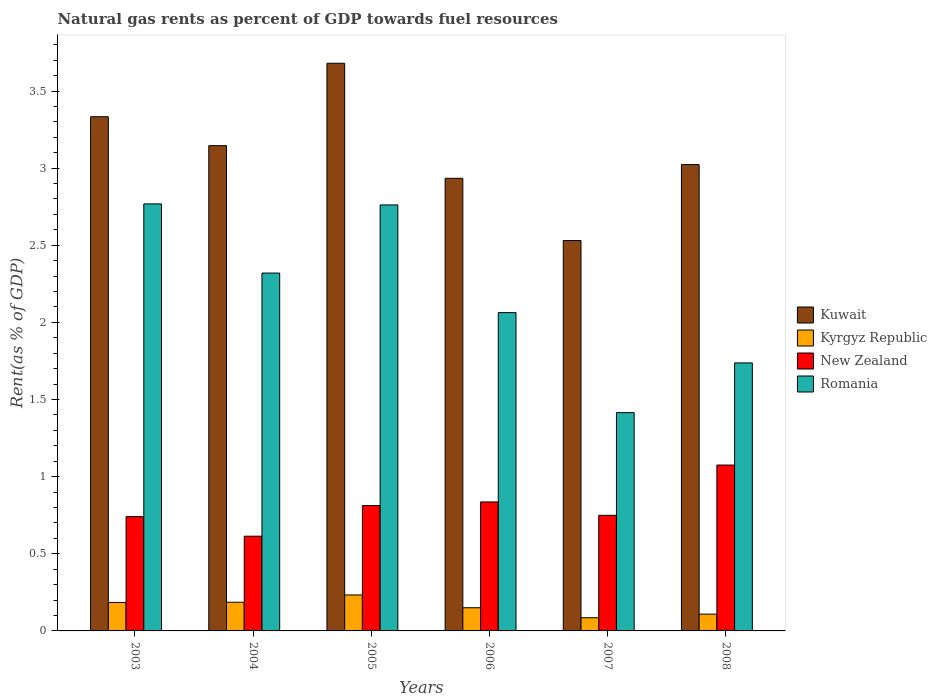How many groups of bars are there?
Give a very brief answer. 6. What is the label of the 6th group of bars from the left?
Your response must be concise. 2008. What is the matural gas rent in New Zealand in 2005?
Give a very brief answer. 0.81. Across all years, what is the maximum matural gas rent in Romania?
Keep it short and to the point. 2.77. Across all years, what is the minimum matural gas rent in Romania?
Offer a very short reply. 1.42. In which year was the matural gas rent in New Zealand maximum?
Offer a terse response. 2008. What is the total matural gas rent in Romania in the graph?
Your response must be concise. 13.07. What is the difference between the matural gas rent in Romania in 2004 and that in 2007?
Ensure brevity in your answer.  0.9. What is the difference between the matural gas rent in Romania in 2008 and the matural gas rent in New Zealand in 2005?
Provide a succinct answer. 0.92. What is the average matural gas rent in New Zealand per year?
Your answer should be compact. 0.8. In the year 2007, what is the difference between the matural gas rent in Romania and matural gas rent in Kyrgyz Republic?
Ensure brevity in your answer.  1.33. What is the ratio of the matural gas rent in New Zealand in 2005 to that in 2006?
Give a very brief answer. 0.97. Is the matural gas rent in Kyrgyz Republic in 2004 less than that in 2006?
Offer a terse response. No. Is the difference between the matural gas rent in Romania in 2004 and 2008 greater than the difference between the matural gas rent in Kyrgyz Republic in 2004 and 2008?
Keep it short and to the point. Yes. What is the difference between the highest and the second highest matural gas rent in Kuwait?
Provide a succinct answer. 0.35. What is the difference between the highest and the lowest matural gas rent in Kyrgyz Republic?
Your answer should be very brief. 0.15. What does the 2nd bar from the left in 2004 represents?
Keep it short and to the point. Kyrgyz Republic. What does the 4th bar from the right in 2007 represents?
Provide a short and direct response. Kuwait. Is it the case that in every year, the sum of the matural gas rent in Kuwait and matural gas rent in Romania is greater than the matural gas rent in New Zealand?
Ensure brevity in your answer.  Yes. How many bars are there?
Provide a succinct answer. 24. Are the values on the major ticks of Y-axis written in scientific E-notation?
Provide a succinct answer. No. Does the graph contain any zero values?
Offer a very short reply. No. How many legend labels are there?
Keep it short and to the point. 4. What is the title of the graph?
Keep it short and to the point. Natural gas rents as percent of GDP towards fuel resources. Does "Sao Tome and Principe" appear as one of the legend labels in the graph?
Offer a very short reply. No. What is the label or title of the Y-axis?
Provide a succinct answer. Rent(as % of GDP). What is the Rent(as % of GDP) of Kuwait in 2003?
Make the answer very short. 3.33. What is the Rent(as % of GDP) of Kyrgyz Republic in 2003?
Your answer should be very brief. 0.18. What is the Rent(as % of GDP) in New Zealand in 2003?
Your answer should be very brief. 0.74. What is the Rent(as % of GDP) of Romania in 2003?
Give a very brief answer. 2.77. What is the Rent(as % of GDP) in Kuwait in 2004?
Your answer should be compact. 3.15. What is the Rent(as % of GDP) of Kyrgyz Republic in 2004?
Ensure brevity in your answer.  0.19. What is the Rent(as % of GDP) in New Zealand in 2004?
Make the answer very short. 0.61. What is the Rent(as % of GDP) of Romania in 2004?
Give a very brief answer. 2.32. What is the Rent(as % of GDP) in Kuwait in 2005?
Ensure brevity in your answer.  3.68. What is the Rent(as % of GDP) in Kyrgyz Republic in 2005?
Make the answer very short. 0.23. What is the Rent(as % of GDP) in New Zealand in 2005?
Provide a succinct answer. 0.81. What is the Rent(as % of GDP) of Romania in 2005?
Offer a very short reply. 2.76. What is the Rent(as % of GDP) of Kuwait in 2006?
Your answer should be compact. 2.93. What is the Rent(as % of GDP) in Kyrgyz Republic in 2006?
Offer a very short reply. 0.15. What is the Rent(as % of GDP) of New Zealand in 2006?
Give a very brief answer. 0.84. What is the Rent(as % of GDP) of Romania in 2006?
Provide a short and direct response. 2.06. What is the Rent(as % of GDP) in Kuwait in 2007?
Give a very brief answer. 2.53. What is the Rent(as % of GDP) of Kyrgyz Republic in 2007?
Offer a terse response. 0.09. What is the Rent(as % of GDP) of New Zealand in 2007?
Make the answer very short. 0.75. What is the Rent(as % of GDP) of Romania in 2007?
Your answer should be very brief. 1.42. What is the Rent(as % of GDP) in Kuwait in 2008?
Provide a succinct answer. 3.02. What is the Rent(as % of GDP) in Kyrgyz Republic in 2008?
Your answer should be very brief. 0.11. What is the Rent(as % of GDP) in New Zealand in 2008?
Your answer should be compact. 1.08. What is the Rent(as % of GDP) in Romania in 2008?
Ensure brevity in your answer.  1.74. Across all years, what is the maximum Rent(as % of GDP) in Kuwait?
Your response must be concise. 3.68. Across all years, what is the maximum Rent(as % of GDP) in Kyrgyz Republic?
Keep it short and to the point. 0.23. Across all years, what is the maximum Rent(as % of GDP) of New Zealand?
Offer a very short reply. 1.08. Across all years, what is the maximum Rent(as % of GDP) of Romania?
Keep it short and to the point. 2.77. Across all years, what is the minimum Rent(as % of GDP) of Kuwait?
Provide a succinct answer. 2.53. Across all years, what is the minimum Rent(as % of GDP) of Kyrgyz Republic?
Your response must be concise. 0.09. Across all years, what is the minimum Rent(as % of GDP) of New Zealand?
Offer a terse response. 0.61. Across all years, what is the minimum Rent(as % of GDP) in Romania?
Your answer should be very brief. 1.42. What is the total Rent(as % of GDP) of Kuwait in the graph?
Provide a short and direct response. 18.65. What is the total Rent(as % of GDP) in Kyrgyz Republic in the graph?
Offer a terse response. 0.95. What is the total Rent(as % of GDP) in New Zealand in the graph?
Provide a short and direct response. 4.83. What is the total Rent(as % of GDP) in Romania in the graph?
Offer a very short reply. 13.07. What is the difference between the Rent(as % of GDP) in Kuwait in 2003 and that in 2004?
Your response must be concise. 0.19. What is the difference between the Rent(as % of GDP) of Kyrgyz Republic in 2003 and that in 2004?
Provide a short and direct response. -0. What is the difference between the Rent(as % of GDP) of New Zealand in 2003 and that in 2004?
Make the answer very short. 0.13. What is the difference between the Rent(as % of GDP) of Romania in 2003 and that in 2004?
Ensure brevity in your answer.  0.45. What is the difference between the Rent(as % of GDP) of Kuwait in 2003 and that in 2005?
Make the answer very short. -0.35. What is the difference between the Rent(as % of GDP) in Kyrgyz Republic in 2003 and that in 2005?
Your response must be concise. -0.05. What is the difference between the Rent(as % of GDP) of New Zealand in 2003 and that in 2005?
Keep it short and to the point. -0.07. What is the difference between the Rent(as % of GDP) of Romania in 2003 and that in 2005?
Your answer should be compact. 0.01. What is the difference between the Rent(as % of GDP) of Kuwait in 2003 and that in 2006?
Your answer should be compact. 0.4. What is the difference between the Rent(as % of GDP) in Kyrgyz Republic in 2003 and that in 2006?
Give a very brief answer. 0.03. What is the difference between the Rent(as % of GDP) in New Zealand in 2003 and that in 2006?
Your answer should be compact. -0.1. What is the difference between the Rent(as % of GDP) of Romania in 2003 and that in 2006?
Provide a short and direct response. 0.7. What is the difference between the Rent(as % of GDP) in Kuwait in 2003 and that in 2007?
Provide a succinct answer. 0.8. What is the difference between the Rent(as % of GDP) of Kyrgyz Republic in 2003 and that in 2007?
Make the answer very short. 0.1. What is the difference between the Rent(as % of GDP) of New Zealand in 2003 and that in 2007?
Provide a short and direct response. -0.01. What is the difference between the Rent(as % of GDP) in Romania in 2003 and that in 2007?
Keep it short and to the point. 1.35. What is the difference between the Rent(as % of GDP) of Kuwait in 2003 and that in 2008?
Offer a terse response. 0.31. What is the difference between the Rent(as % of GDP) of Kyrgyz Republic in 2003 and that in 2008?
Your answer should be very brief. 0.08. What is the difference between the Rent(as % of GDP) in New Zealand in 2003 and that in 2008?
Give a very brief answer. -0.33. What is the difference between the Rent(as % of GDP) in Romania in 2003 and that in 2008?
Offer a very short reply. 1.03. What is the difference between the Rent(as % of GDP) in Kuwait in 2004 and that in 2005?
Your response must be concise. -0.53. What is the difference between the Rent(as % of GDP) in Kyrgyz Republic in 2004 and that in 2005?
Your response must be concise. -0.05. What is the difference between the Rent(as % of GDP) of New Zealand in 2004 and that in 2005?
Your response must be concise. -0.2. What is the difference between the Rent(as % of GDP) in Romania in 2004 and that in 2005?
Offer a terse response. -0.44. What is the difference between the Rent(as % of GDP) in Kuwait in 2004 and that in 2006?
Offer a very short reply. 0.21. What is the difference between the Rent(as % of GDP) of Kyrgyz Republic in 2004 and that in 2006?
Offer a terse response. 0.04. What is the difference between the Rent(as % of GDP) in New Zealand in 2004 and that in 2006?
Ensure brevity in your answer.  -0.22. What is the difference between the Rent(as % of GDP) of Romania in 2004 and that in 2006?
Give a very brief answer. 0.26. What is the difference between the Rent(as % of GDP) in Kuwait in 2004 and that in 2007?
Offer a terse response. 0.61. What is the difference between the Rent(as % of GDP) in Kyrgyz Republic in 2004 and that in 2007?
Your answer should be compact. 0.1. What is the difference between the Rent(as % of GDP) in New Zealand in 2004 and that in 2007?
Provide a succinct answer. -0.14. What is the difference between the Rent(as % of GDP) in Romania in 2004 and that in 2007?
Provide a succinct answer. 0.9. What is the difference between the Rent(as % of GDP) of Kuwait in 2004 and that in 2008?
Offer a terse response. 0.12. What is the difference between the Rent(as % of GDP) of Kyrgyz Republic in 2004 and that in 2008?
Your answer should be very brief. 0.08. What is the difference between the Rent(as % of GDP) in New Zealand in 2004 and that in 2008?
Your answer should be compact. -0.46. What is the difference between the Rent(as % of GDP) in Romania in 2004 and that in 2008?
Your answer should be very brief. 0.58. What is the difference between the Rent(as % of GDP) in Kuwait in 2005 and that in 2006?
Offer a terse response. 0.75. What is the difference between the Rent(as % of GDP) in Kyrgyz Republic in 2005 and that in 2006?
Ensure brevity in your answer.  0.08. What is the difference between the Rent(as % of GDP) of New Zealand in 2005 and that in 2006?
Keep it short and to the point. -0.02. What is the difference between the Rent(as % of GDP) in Romania in 2005 and that in 2006?
Your answer should be compact. 0.7. What is the difference between the Rent(as % of GDP) in Kuwait in 2005 and that in 2007?
Your answer should be very brief. 1.15. What is the difference between the Rent(as % of GDP) in Kyrgyz Republic in 2005 and that in 2007?
Offer a terse response. 0.15. What is the difference between the Rent(as % of GDP) of New Zealand in 2005 and that in 2007?
Ensure brevity in your answer.  0.06. What is the difference between the Rent(as % of GDP) in Romania in 2005 and that in 2007?
Offer a very short reply. 1.35. What is the difference between the Rent(as % of GDP) of Kuwait in 2005 and that in 2008?
Offer a very short reply. 0.66. What is the difference between the Rent(as % of GDP) of Kyrgyz Republic in 2005 and that in 2008?
Keep it short and to the point. 0.12. What is the difference between the Rent(as % of GDP) of New Zealand in 2005 and that in 2008?
Offer a terse response. -0.26. What is the difference between the Rent(as % of GDP) of Romania in 2005 and that in 2008?
Your answer should be compact. 1.02. What is the difference between the Rent(as % of GDP) of Kuwait in 2006 and that in 2007?
Ensure brevity in your answer.  0.4. What is the difference between the Rent(as % of GDP) in Kyrgyz Republic in 2006 and that in 2007?
Your answer should be very brief. 0.06. What is the difference between the Rent(as % of GDP) in New Zealand in 2006 and that in 2007?
Give a very brief answer. 0.09. What is the difference between the Rent(as % of GDP) in Romania in 2006 and that in 2007?
Your answer should be compact. 0.65. What is the difference between the Rent(as % of GDP) in Kuwait in 2006 and that in 2008?
Give a very brief answer. -0.09. What is the difference between the Rent(as % of GDP) of Kyrgyz Republic in 2006 and that in 2008?
Offer a very short reply. 0.04. What is the difference between the Rent(as % of GDP) of New Zealand in 2006 and that in 2008?
Give a very brief answer. -0.24. What is the difference between the Rent(as % of GDP) of Romania in 2006 and that in 2008?
Your answer should be compact. 0.33. What is the difference between the Rent(as % of GDP) of Kuwait in 2007 and that in 2008?
Your answer should be compact. -0.49. What is the difference between the Rent(as % of GDP) of Kyrgyz Republic in 2007 and that in 2008?
Offer a very short reply. -0.02. What is the difference between the Rent(as % of GDP) in New Zealand in 2007 and that in 2008?
Your response must be concise. -0.33. What is the difference between the Rent(as % of GDP) of Romania in 2007 and that in 2008?
Your response must be concise. -0.32. What is the difference between the Rent(as % of GDP) in Kuwait in 2003 and the Rent(as % of GDP) in Kyrgyz Republic in 2004?
Offer a terse response. 3.15. What is the difference between the Rent(as % of GDP) of Kuwait in 2003 and the Rent(as % of GDP) of New Zealand in 2004?
Your answer should be very brief. 2.72. What is the difference between the Rent(as % of GDP) in Kuwait in 2003 and the Rent(as % of GDP) in Romania in 2004?
Ensure brevity in your answer.  1.01. What is the difference between the Rent(as % of GDP) of Kyrgyz Republic in 2003 and the Rent(as % of GDP) of New Zealand in 2004?
Ensure brevity in your answer.  -0.43. What is the difference between the Rent(as % of GDP) in Kyrgyz Republic in 2003 and the Rent(as % of GDP) in Romania in 2004?
Offer a very short reply. -2.14. What is the difference between the Rent(as % of GDP) in New Zealand in 2003 and the Rent(as % of GDP) in Romania in 2004?
Your answer should be compact. -1.58. What is the difference between the Rent(as % of GDP) in Kuwait in 2003 and the Rent(as % of GDP) in Kyrgyz Republic in 2005?
Your response must be concise. 3.1. What is the difference between the Rent(as % of GDP) in Kuwait in 2003 and the Rent(as % of GDP) in New Zealand in 2005?
Provide a succinct answer. 2.52. What is the difference between the Rent(as % of GDP) in Kuwait in 2003 and the Rent(as % of GDP) in Romania in 2005?
Give a very brief answer. 0.57. What is the difference between the Rent(as % of GDP) in Kyrgyz Republic in 2003 and the Rent(as % of GDP) in New Zealand in 2005?
Ensure brevity in your answer.  -0.63. What is the difference between the Rent(as % of GDP) in Kyrgyz Republic in 2003 and the Rent(as % of GDP) in Romania in 2005?
Ensure brevity in your answer.  -2.58. What is the difference between the Rent(as % of GDP) of New Zealand in 2003 and the Rent(as % of GDP) of Romania in 2005?
Your answer should be compact. -2.02. What is the difference between the Rent(as % of GDP) in Kuwait in 2003 and the Rent(as % of GDP) in Kyrgyz Republic in 2006?
Give a very brief answer. 3.18. What is the difference between the Rent(as % of GDP) in Kuwait in 2003 and the Rent(as % of GDP) in New Zealand in 2006?
Offer a terse response. 2.5. What is the difference between the Rent(as % of GDP) of Kuwait in 2003 and the Rent(as % of GDP) of Romania in 2006?
Give a very brief answer. 1.27. What is the difference between the Rent(as % of GDP) in Kyrgyz Republic in 2003 and the Rent(as % of GDP) in New Zealand in 2006?
Provide a short and direct response. -0.65. What is the difference between the Rent(as % of GDP) of Kyrgyz Republic in 2003 and the Rent(as % of GDP) of Romania in 2006?
Your response must be concise. -1.88. What is the difference between the Rent(as % of GDP) in New Zealand in 2003 and the Rent(as % of GDP) in Romania in 2006?
Offer a very short reply. -1.32. What is the difference between the Rent(as % of GDP) of Kuwait in 2003 and the Rent(as % of GDP) of Kyrgyz Republic in 2007?
Provide a succinct answer. 3.25. What is the difference between the Rent(as % of GDP) of Kuwait in 2003 and the Rent(as % of GDP) of New Zealand in 2007?
Keep it short and to the point. 2.58. What is the difference between the Rent(as % of GDP) of Kuwait in 2003 and the Rent(as % of GDP) of Romania in 2007?
Your answer should be very brief. 1.92. What is the difference between the Rent(as % of GDP) of Kyrgyz Republic in 2003 and the Rent(as % of GDP) of New Zealand in 2007?
Keep it short and to the point. -0.56. What is the difference between the Rent(as % of GDP) of Kyrgyz Republic in 2003 and the Rent(as % of GDP) of Romania in 2007?
Make the answer very short. -1.23. What is the difference between the Rent(as % of GDP) of New Zealand in 2003 and the Rent(as % of GDP) of Romania in 2007?
Make the answer very short. -0.67. What is the difference between the Rent(as % of GDP) in Kuwait in 2003 and the Rent(as % of GDP) in Kyrgyz Republic in 2008?
Your response must be concise. 3.22. What is the difference between the Rent(as % of GDP) in Kuwait in 2003 and the Rent(as % of GDP) in New Zealand in 2008?
Provide a succinct answer. 2.26. What is the difference between the Rent(as % of GDP) in Kuwait in 2003 and the Rent(as % of GDP) in Romania in 2008?
Provide a succinct answer. 1.6. What is the difference between the Rent(as % of GDP) of Kyrgyz Republic in 2003 and the Rent(as % of GDP) of New Zealand in 2008?
Provide a short and direct response. -0.89. What is the difference between the Rent(as % of GDP) in Kyrgyz Republic in 2003 and the Rent(as % of GDP) in Romania in 2008?
Offer a terse response. -1.55. What is the difference between the Rent(as % of GDP) of New Zealand in 2003 and the Rent(as % of GDP) of Romania in 2008?
Your response must be concise. -1. What is the difference between the Rent(as % of GDP) of Kuwait in 2004 and the Rent(as % of GDP) of Kyrgyz Republic in 2005?
Keep it short and to the point. 2.91. What is the difference between the Rent(as % of GDP) of Kuwait in 2004 and the Rent(as % of GDP) of New Zealand in 2005?
Offer a terse response. 2.33. What is the difference between the Rent(as % of GDP) in Kuwait in 2004 and the Rent(as % of GDP) in Romania in 2005?
Your answer should be very brief. 0.38. What is the difference between the Rent(as % of GDP) in Kyrgyz Republic in 2004 and the Rent(as % of GDP) in New Zealand in 2005?
Offer a terse response. -0.63. What is the difference between the Rent(as % of GDP) of Kyrgyz Republic in 2004 and the Rent(as % of GDP) of Romania in 2005?
Your response must be concise. -2.58. What is the difference between the Rent(as % of GDP) of New Zealand in 2004 and the Rent(as % of GDP) of Romania in 2005?
Keep it short and to the point. -2.15. What is the difference between the Rent(as % of GDP) in Kuwait in 2004 and the Rent(as % of GDP) in Kyrgyz Republic in 2006?
Make the answer very short. 3. What is the difference between the Rent(as % of GDP) in Kuwait in 2004 and the Rent(as % of GDP) in New Zealand in 2006?
Your answer should be very brief. 2.31. What is the difference between the Rent(as % of GDP) in Kuwait in 2004 and the Rent(as % of GDP) in Romania in 2006?
Your answer should be compact. 1.08. What is the difference between the Rent(as % of GDP) in Kyrgyz Republic in 2004 and the Rent(as % of GDP) in New Zealand in 2006?
Ensure brevity in your answer.  -0.65. What is the difference between the Rent(as % of GDP) of Kyrgyz Republic in 2004 and the Rent(as % of GDP) of Romania in 2006?
Keep it short and to the point. -1.88. What is the difference between the Rent(as % of GDP) of New Zealand in 2004 and the Rent(as % of GDP) of Romania in 2006?
Offer a terse response. -1.45. What is the difference between the Rent(as % of GDP) in Kuwait in 2004 and the Rent(as % of GDP) in Kyrgyz Republic in 2007?
Your response must be concise. 3.06. What is the difference between the Rent(as % of GDP) of Kuwait in 2004 and the Rent(as % of GDP) of New Zealand in 2007?
Offer a terse response. 2.4. What is the difference between the Rent(as % of GDP) in Kuwait in 2004 and the Rent(as % of GDP) in Romania in 2007?
Make the answer very short. 1.73. What is the difference between the Rent(as % of GDP) of Kyrgyz Republic in 2004 and the Rent(as % of GDP) of New Zealand in 2007?
Ensure brevity in your answer.  -0.56. What is the difference between the Rent(as % of GDP) in Kyrgyz Republic in 2004 and the Rent(as % of GDP) in Romania in 2007?
Your answer should be very brief. -1.23. What is the difference between the Rent(as % of GDP) of New Zealand in 2004 and the Rent(as % of GDP) of Romania in 2007?
Give a very brief answer. -0.8. What is the difference between the Rent(as % of GDP) of Kuwait in 2004 and the Rent(as % of GDP) of Kyrgyz Republic in 2008?
Offer a very short reply. 3.04. What is the difference between the Rent(as % of GDP) of Kuwait in 2004 and the Rent(as % of GDP) of New Zealand in 2008?
Offer a very short reply. 2.07. What is the difference between the Rent(as % of GDP) in Kuwait in 2004 and the Rent(as % of GDP) in Romania in 2008?
Offer a very short reply. 1.41. What is the difference between the Rent(as % of GDP) in Kyrgyz Republic in 2004 and the Rent(as % of GDP) in New Zealand in 2008?
Offer a very short reply. -0.89. What is the difference between the Rent(as % of GDP) in Kyrgyz Republic in 2004 and the Rent(as % of GDP) in Romania in 2008?
Give a very brief answer. -1.55. What is the difference between the Rent(as % of GDP) in New Zealand in 2004 and the Rent(as % of GDP) in Romania in 2008?
Offer a terse response. -1.12. What is the difference between the Rent(as % of GDP) in Kuwait in 2005 and the Rent(as % of GDP) in Kyrgyz Republic in 2006?
Keep it short and to the point. 3.53. What is the difference between the Rent(as % of GDP) of Kuwait in 2005 and the Rent(as % of GDP) of New Zealand in 2006?
Your answer should be very brief. 2.84. What is the difference between the Rent(as % of GDP) of Kuwait in 2005 and the Rent(as % of GDP) of Romania in 2006?
Provide a short and direct response. 1.62. What is the difference between the Rent(as % of GDP) in Kyrgyz Republic in 2005 and the Rent(as % of GDP) in New Zealand in 2006?
Your response must be concise. -0.6. What is the difference between the Rent(as % of GDP) of Kyrgyz Republic in 2005 and the Rent(as % of GDP) of Romania in 2006?
Keep it short and to the point. -1.83. What is the difference between the Rent(as % of GDP) of New Zealand in 2005 and the Rent(as % of GDP) of Romania in 2006?
Offer a very short reply. -1.25. What is the difference between the Rent(as % of GDP) of Kuwait in 2005 and the Rent(as % of GDP) of Kyrgyz Republic in 2007?
Make the answer very short. 3.59. What is the difference between the Rent(as % of GDP) in Kuwait in 2005 and the Rent(as % of GDP) in New Zealand in 2007?
Your answer should be very brief. 2.93. What is the difference between the Rent(as % of GDP) of Kuwait in 2005 and the Rent(as % of GDP) of Romania in 2007?
Keep it short and to the point. 2.26. What is the difference between the Rent(as % of GDP) in Kyrgyz Republic in 2005 and the Rent(as % of GDP) in New Zealand in 2007?
Make the answer very short. -0.52. What is the difference between the Rent(as % of GDP) of Kyrgyz Republic in 2005 and the Rent(as % of GDP) of Romania in 2007?
Provide a succinct answer. -1.18. What is the difference between the Rent(as % of GDP) in New Zealand in 2005 and the Rent(as % of GDP) in Romania in 2007?
Make the answer very short. -0.6. What is the difference between the Rent(as % of GDP) of Kuwait in 2005 and the Rent(as % of GDP) of Kyrgyz Republic in 2008?
Provide a short and direct response. 3.57. What is the difference between the Rent(as % of GDP) in Kuwait in 2005 and the Rent(as % of GDP) in New Zealand in 2008?
Your response must be concise. 2.6. What is the difference between the Rent(as % of GDP) of Kuwait in 2005 and the Rent(as % of GDP) of Romania in 2008?
Give a very brief answer. 1.94. What is the difference between the Rent(as % of GDP) of Kyrgyz Republic in 2005 and the Rent(as % of GDP) of New Zealand in 2008?
Your answer should be very brief. -0.84. What is the difference between the Rent(as % of GDP) in Kyrgyz Republic in 2005 and the Rent(as % of GDP) in Romania in 2008?
Make the answer very short. -1.5. What is the difference between the Rent(as % of GDP) in New Zealand in 2005 and the Rent(as % of GDP) in Romania in 2008?
Ensure brevity in your answer.  -0.92. What is the difference between the Rent(as % of GDP) of Kuwait in 2006 and the Rent(as % of GDP) of Kyrgyz Republic in 2007?
Offer a terse response. 2.85. What is the difference between the Rent(as % of GDP) of Kuwait in 2006 and the Rent(as % of GDP) of New Zealand in 2007?
Your answer should be compact. 2.18. What is the difference between the Rent(as % of GDP) in Kuwait in 2006 and the Rent(as % of GDP) in Romania in 2007?
Make the answer very short. 1.52. What is the difference between the Rent(as % of GDP) of Kyrgyz Republic in 2006 and the Rent(as % of GDP) of New Zealand in 2007?
Your response must be concise. -0.6. What is the difference between the Rent(as % of GDP) of Kyrgyz Republic in 2006 and the Rent(as % of GDP) of Romania in 2007?
Your answer should be compact. -1.26. What is the difference between the Rent(as % of GDP) of New Zealand in 2006 and the Rent(as % of GDP) of Romania in 2007?
Keep it short and to the point. -0.58. What is the difference between the Rent(as % of GDP) in Kuwait in 2006 and the Rent(as % of GDP) in Kyrgyz Republic in 2008?
Offer a terse response. 2.83. What is the difference between the Rent(as % of GDP) in Kuwait in 2006 and the Rent(as % of GDP) in New Zealand in 2008?
Offer a terse response. 1.86. What is the difference between the Rent(as % of GDP) in Kuwait in 2006 and the Rent(as % of GDP) in Romania in 2008?
Offer a very short reply. 1.2. What is the difference between the Rent(as % of GDP) of Kyrgyz Republic in 2006 and the Rent(as % of GDP) of New Zealand in 2008?
Provide a short and direct response. -0.93. What is the difference between the Rent(as % of GDP) of Kyrgyz Republic in 2006 and the Rent(as % of GDP) of Romania in 2008?
Keep it short and to the point. -1.59. What is the difference between the Rent(as % of GDP) of New Zealand in 2006 and the Rent(as % of GDP) of Romania in 2008?
Keep it short and to the point. -0.9. What is the difference between the Rent(as % of GDP) in Kuwait in 2007 and the Rent(as % of GDP) in Kyrgyz Republic in 2008?
Make the answer very short. 2.42. What is the difference between the Rent(as % of GDP) in Kuwait in 2007 and the Rent(as % of GDP) in New Zealand in 2008?
Your answer should be very brief. 1.46. What is the difference between the Rent(as % of GDP) of Kuwait in 2007 and the Rent(as % of GDP) of Romania in 2008?
Ensure brevity in your answer.  0.79. What is the difference between the Rent(as % of GDP) in Kyrgyz Republic in 2007 and the Rent(as % of GDP) in New Zealand in 2008?
Give a very brief answer. -0.99. What is the difference between the Rent(as % of GDP) of Kyrgyz Republic in 2007 and the Rent(as % of GDP) of Romania in 2008?
Your answer should be very brief. -1.65. What is the difference between the Rent(as % of GDP) in New Zealand in 2007 and the Rent(as % of GDP) in Romania in 2008?
Provide a short and direct response. -0.99. What is the average Rent(as % of GDP) of Kuwait per year?
Your answer should be compact. 3.11. What is the average Rent(as % of GDP) of Kyrgyz Republic per year?
Offer a terse response. 0.16. What is the average Rent(as % of GDP) in New Zealand per year?
Your answer should be compact. 0.8. What is the average Rent(as % of GDP) in Romania per year?
Provide a succinct answer. 2.18. In the year 2003, what is the difference between the Rent(as % of GDP) of Kuwait and Rent(as % of GDP) of Kyrgyz Republic?
Provide a succinct answer. 3.15. In the year 2003, what is the difference between the Rent(as % of GDP) in Kuwait and Rent(as % of GDP) in New Zealand?
Provide a short and direct response. 2.59. In the year 2003, what is the difference between the Rent(as % of GDP) of Kuwait and Rent(as % of GDP) of Romania?
Provide a succinct answer. 0.57. In the year 2003, what is the difference between the Rent(as % of GDP) in Kyrgyz Republic and Rent(as % of GDP) in New Zealand?
Your answer should be very brief. -0.56. In the year 2003, what is the difference between the Rent(as % of GDP) of Kyrgyz Republic and Rent(as % of GDP) of Romania?
Offer a very short reply. -2.58. In the year 2003, what is the difference between the Rent(as % of GDP) of New Zealand and Rent(as % of GDP) of Romania?
Your answer should be compact. -2.03. In the year 2004, what is the difference between the Rent(as % of GDP) of Kuwait and Rent(as % of GDP) of Kyrgyz Republic?
Provide a succinct answer. 2.96. In the year 2004, what is the difference between the Rent(as % of GDP) of Kuwait and Rent(as % of GDP) of New Zealand?
Your response must be concise. 2.53. In the year 2004, what is the difference between the Rent(as % of GDP) of Kuwait and Rent(as % of GDP) of Romania?
Make the answer very short. 0.83. In the year 2004, what is the difference between the Rent(as % of GDP) in Kyrgyz Republic and Rent(as % of GDP) in New Zealand?
Provide a succinct answer. -0.43. In the year 2004, what is the difference between the Rent(as % of GDP) of Kyrgyz Republic and Rent(as % of GDP) of Romania?
Ensure brevity in your answer.  -2.13. In the year 2004, what is the difference between the Rent(as % of GDP) of New Zealand and Rent(as % of GDP) of Romania?
Offer a terse response. -1.71. In the year 2005, what is the difference between the Rent(as % of GDP) in Kuwait and Rent(as % of GDP) in Kyrgyz Republic?
Your answer should be compact. 3.45. In the year 2005, what is the difference between the Rent(as % of GDP) of Kuwait and Rent(as % of GDP) of New Zealand?
Offer a very short reply. 2.87. In the year 2005, what is the difference between the Rent(as % of GDP) of Kuwait and Rent(as % of GDP) of Romania?
Your response must be concise. 0.92. In the year 2005, what is the difference between the Rent(as % of GDP) in Kyrgyz Republic and Rent(as % of GDP) in New Zealand?
Keep it short and to the point. -0.58. In the year 2005, what is the difference between the Rent(as % of GDP) in Kyrgyz Republic and Rent(as % of GDP) in Romania?
Provide a short and direct response. -2.53. In the year 2005, what is the difference between the Rent(as % of GDP) of New Zealand and Rent(as % of GDP) of Romania?
Keep it short and to the point. -1.95. In the year 2006, what is the difference between the Rent(as % of GDP) of Kuwait and Rent(as % of GDP) of Kyrgyz Republic?
Your answer should be compact. 2.78. In the year 2006, what is the difference between the Rent(as % of GDP) in Kuwait and Rent(as % of GDP) in New Zealand?
Offer a terse response. 2.1. In the year 2006, what is the difference between the Rent(as % of GDP) in Kuwait and Rent(as % of GDP) in Romania?
Offer a very short reply. 0.87. In the year 2006, what is the difference between the Rent(as % of GDP) of Kyrgyz Republic and Rent(as % of GDP) of New Zealand?
Make the answer very short. -0.69. In the year 2006, what is the difference between the Rent(as % of GDP) in Kyrgyz Republic and Rent(as % of GDP) in Romania?
Make the answer very short. -1.91. In the year 2006, what is the difference between the Rent(as % of GDP) of New Zealand and Rent(as % of GDP) of Romania?
Ensure brevity in your answer.  -1.23. In the year 2007, what is the difference between the Rent(as % of GDP) in Kuwait and Rent(as % of GDP) in Kyrgyz Republic?
Offer a terse response. 2.45. In the year 2007, what is the difference between the Rent(as % of GDP) in Kuwait and Rent(as % of GDP) in New Zealand?
Your answer should be very brief. 1.78. In the year 2007, what is the difference between the Rent(as % of GDP) in Kuwait and Rent(as % of GDP) in Romania?
Your answer should be very brief. 1.12. In the year 2007, what is the difference between the Rent(as % of GDP) of Kyrgyz Republic and Rent(as % of GDP) of New Zealand?
Offer a very short reply. -0.66. In the year 2007, what is the difference between the Rent(as % of GDP) in Kyrgyz Republic and Rent(as % of GDP) in Romania?
Your response must be concise. -1.33. In the year 2007, what is the difference between the Rent(as % of GDP) of New Zealand and Rent(as % of GDP) of Romania?
Give a very brief answer. -0.67. In the year 2008, what is the difference between the Rent(as % of GDP) in Kuwait and Rent(as % of GDP) in Kyrgyz Republic?
Your answer should be very brief. 2.91. In the year 2008, what is the difference between the Rent(as % of GDP) of Kuwait and Rent(as % of GDP) of New Zealand?
Your response must be concise. 1.95. In the year 2008, what is the difference between the Rent(as % of GDP) in Kuwait and Rent(as % of GDP) in Romania?
Make the answer very short. 1.29. In the year 2008, what is the difference between the Rent(as % of GDP) of Kyrgyz Republic and Rent(as % of GDP) of New Zealand?
Keep it short and to the point. -0.97. In the year 2008, what is the difference between the Rent(as % of GDP) of Kyrgyz Republic and Rent(as % of GDP) of Romania?
Provide a succinct answer. -1.63. In the year 2008, what is the difference between the Rent(as % of GDP) of New Zealand and Rent(as % of GDP) of Romania?
Make the answer very short. -0.66. What is the ratio of the Rent(as % of GDP) of Kuwait in 2003 to that in 2004?
Provide a short and direct response. 1.06. What is the ratio of the Rent(as % of GDP) of Kyrgyz Republic in 2003 to that in 2004?
Your answer should be compact. 0.99. What is the ratio of the Rent(as % of GDP) in New Zealand in 2003 to that in 2004?
Your answer should be very brief. 1.21. What is the ratio of the Rent(as % of GDP) in Romania in 2003 to that in 2004?
Provide a short and direct response. 1.19. What is the ratio of the Rent(as % of GDP) in Kuwait in 2003 to that in 2005?
Keep it short and to the point. 0.91. What is the ratio of the Rent(as % of GDP) of Kyrgyz Republic in 2003 to that in 2005?
Offer a terse response. 0.79. What is the ratio of the Rent(as % of GDP) of New Zealand in 2003 to that in 2005?
Your response must be concise. 0.91. What is the ratio of the Rent(as % of GDP) in Romania in 2003 to that in 2005?
Give a very brief answer. 1. What is the ratio of the Rent(as % of GDP) in Kuwait in 2003 to that in 2006?
Offer a very short reply. 1.14. What is the ratio of the Rent(as % of GDP) in Kyrgyz Republic in 2003 to that in 2006?
Offer a terse response. 1.23. What is the ratio of the Rent(as % of GDP) in New Zealand in 2003 to that in 2006?
Your answer should be compact. 0.89. What is the ratio of the Rent(as % of GDP) of Romania in 2003 to that in 2006?
Your response must be concise. 1.34. What is the ratio of the Rent(as % of GDP) of Kuwait in 2003 to that in 2007?
Make the answer very short. 1.32. What is the ratio of the Rent(as % of GDP) of Kyrgyz Republic in 2003 to that in 2007?
Provide a short and direct response. 2.16. What is the ratio of the Rent(as % of GDP) in Romania in 2003 to that in 2007?
Give a very brief answer. 1.96. What is the ratio of the Rent(as % of GDP) in Kuwait in 2003 to that in 2008?
Provide a succinct answer. 1.1. What is the ratio of the Rent(as % of GDP) of Kyrgyz Republic in 2003 to that in 2008?
Ensure brevity in your answer.  1.69. What is the ratio of the Rent(as % of GDP) of New Zealand in 2003 to that in 2008?
Provide a short and direct response. 0.69. What is the ratio of the Rent(as % of GDP) of Romania in 2003 to that in 2008?
Offer a terse response. 1.59. What is the ratio of the Rent(as % of GDP) in Kuwait in 2004 to that in 2005?
Your answer should be compact. 0.85. What is the ratio of the Rent(as % of GDP) in Kyrgyz Republic in 2004 to that in 2005?
Your answer should be compact. 0.8. What is the ratio of the Rent(as % of GDP) of New Zealand in 2004 to that in 2005?
Your answer should be compact. 0.76. What is the ratio of the Rent(as % of GDP) of Romania in 2004 to that in 2005?
Your answer should be compact. 0.84. What is the ratio of the Rent(as % of GDP) in Kuwait in 2004 to that in 2006?
Give a very brief answer. 1.07. What is the ratio of the Rent(as % of GDP) in Kyrgyz Republic in 2004 to that in 2006?
Make the answer very short. 1.24. What is the ratio of the Rent(as % of GDP) in New Zealand in 2004 to that in 2006?
Ensure brevity in your answer.  0.73. What is the ratio of the Rent(as % of GDP) of Romania in 2004 to that in 2006?
Give a very brief answer. 1.12. What is the ratio of the Rent(as % of GDP) in Kuwait in 2004 to that in 2007?
Provide a short and direct response. 1.24. What is the ratio of the Rent(as % of GDP) of Kyrgyz Republic in 2004 to that in 2007?
Provide a succinct answer. 2.17. What is the ratio of the Rent(as % of GDP) in New Zealand in 2004 to that in 2007?
Give a very brief answer. 0.82. What is the ratio of the Rent(as % of GDP) in Romania in 2004 to that in 2007?
Offer a terse response. 1.64. What is the ratio of the Rent(as % of GDP) in Kuwait in 2004 to that in 2008?
Offer a terse response. 1.04. What is the ratio of the Rent(as % of GDP) of Kyrgyz Republic in 2004 to that in 2008?
Keep it short and to the point. 1.71. What is the ratio of the Rent(as % of GDP) in New Zealand in 2004 to that in 2008?
Make the answer very short. 0.57. What is the ratio of the Rent(as % of GDP) of Romania in 2004 to that in 2008?
Make the answer very short. 1.34. What is the ratio of the Rent(as % of GDP) of Kuwait in 2005 to that in 2006?
Ensure brevity in your answer.  1.25. What is the ratio of the Rent(as % of GDP) of Kyrgyz Republic in 2005 to that in 2006?
Make the answer very short. 1.55. What is the ratio of the Rent(as % of GDP) in New Zealand in 2005 to that in 2006?
Give a very brief answer. 0.97. What is the ratio of the Rent(as % of GDP) of Romania in 2005 to that in 2006?
Your answer should be compact. 1.34. What is the ratio of the Rent(as % of GDP) in Kuwait in 2005 to that in 2007?
Offer a very short reply. 1.45. What is the ratio of the Rent(as % of GDP) in Kyrgyz Republic in 2005 to that in 2007?
Your answer should be very brief. 2.73. What is the ratio of the Rent(as % of GDP) in New Zealand in 2005 to that in 2007?
Offer a very short reply. 1.08. What is the ratio of the Rent(as % of GDP) of Romania in 2005 to that in 2007?
Provide a succinct answer. 1.95. What is the ratio of the Rent(as % of GDP) in Kuwait in 2005 to that in 2008?
Offer a very short reply. 1.22. What is the ratio of the Rent(as % of GDP) of Kyrgyz Republic in 2005 to that in 2008?
Your answer should be compact. 2.14. What is the ratio of the Rent(as % of GDP) in New Zealand in 2005 to that in 2008?
Ensure brevity in your answer.  0.76. What is the ratio of the Rent(as % of GDP) in Romania in 2005 to that in 2008?
Your response must be concise. 1.59. What is the ratio of the Rent(as % of GDP) of Kuwait in 2006 to that in 2007?
Your response must be concise. 1.16. What is the ratio of the Rent(as % of GDP) of Kyrgyz Republic in 2006 to that in 2007?
Make the answer very short. 1.76. What is the ratio of the Rent(as % of GDP) in New Zealand in 2006 to that in 2007?
Offer a very short reply. 1.12. What is the ratio of the Rent(as % of GDP) in Romania in 2006 to that in 2007?
Offer a terse response. 1.46. What is the ratio of the Rent(as % of GDP) of Kuwait in 2006 to that in 2008?
Your answer should be compact. 0.97. What is the ratio of the Rent(as % of GDP) of Kyrgyz Republic in 2006 to that in 2008?
Give a very brief answer. 1.38. What is the ratio of the Rent(as % of GDP) of New Zealand in 2006 to that in 2008?
Provide a short and direct response. 0.78. What is the ratio of the Rent(as % of GDP) in Romania in 2006 to that in 2008?
Provide a succinct answer. 1.19. What is the ratio of the Rent(as % of GDP) of Kuwait in 2007 to that in 2008?
Provide a succinct answer. 0.84. What is the ratio of the Rent(as % of GDP) of Kyrgyz Republic in 2007 to that in 2008?
Provide a short and direct response. 0.79. What is the ratio of the Rent(as % of GDP) in New Zealand in 2007 to that in 2008?
Provide a succinct answer. 0.7. What is the ratio of the Rent(as % of GDP) in Romania in 2007 to that in 2008?
Provide a succinct answer. 0.81. What is the difference between the highest and the second highest Rent(as % of GDP) in Kuwait?
Offer a very short reply. 0.35. What is the difference between the highest and the second highest Rent(as % of GDP) of Kyrgyz Republic?
Your answer should be very brief. 0.05. What is the difference between the highest and the second highest Rent(as % of GDP) of New Zealand?
Keep it short and to the point. 0.24. What is the difference between the highest and the second highest Rent(as % of GDP) in Romania?
Offer a very short reply. 0.01. What is the difference between the highest and the lowest Rent(as % of GDP) of Kuwait?
Make the answer very short. 1.15. What is the difference between the highest and the lowest Rent(as % of GDP) of Kyrgyz Republic?
Offer a very short reply. 0.15. What is the difference between the highest and the lowest Rent(as % of GDP) of New Zealand?
Give a very brief answer. 0.46. What is the difference between the highest and the lowest Rent(as % of GDP) in Romania?
Your response must be concise. 1.35. 